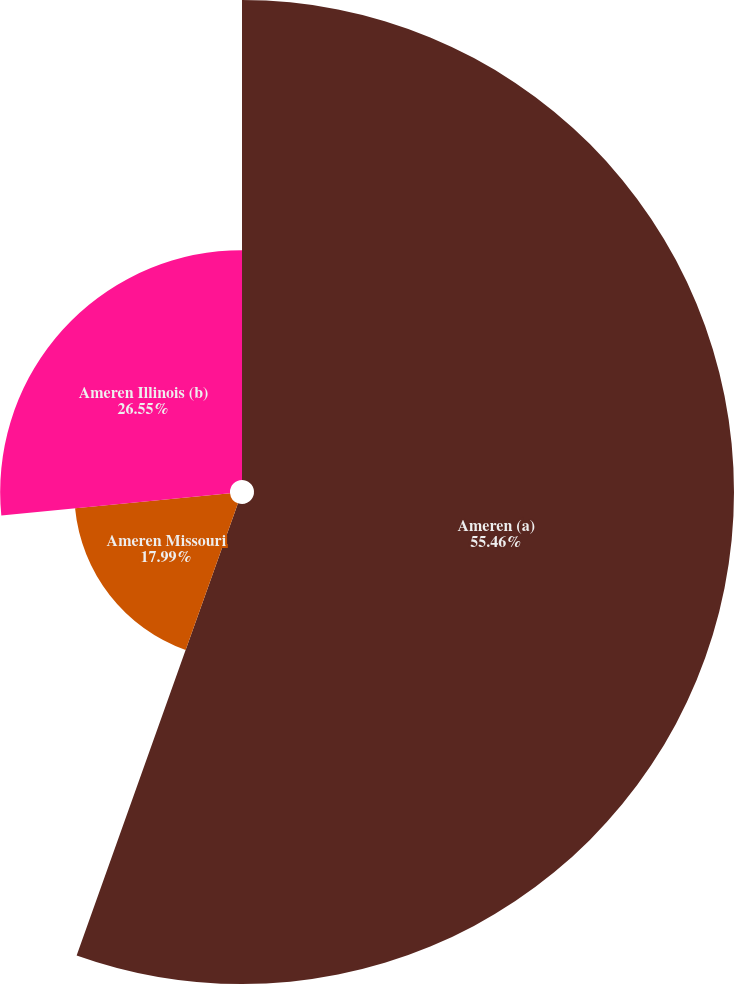<chart> <loc_0><loc_0><loc_500><loc_500><pie_chart><fcel>Ameren (a)<fcel>Ameren Missouri<fcel>Ameren Illinois (b)<nl><fcel>55.45%<fcel>17.99%<fcel>26.55%<nl></chart> 